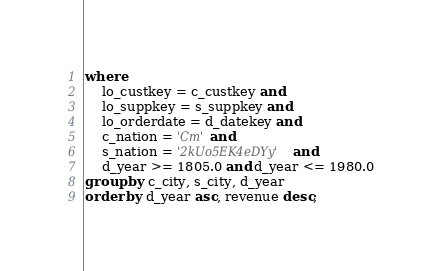<code> <loc_0><loc_0><loc_500><loc_500><_SQL_>where
    lo_custkey = c_custkey and
    lo_suppkey = s_suppkey and
    lo_orderdate = d_datekey and
    c_nation = 'Cm' and
    s_nation = '2kUo5EK4eDYy' and
    d_year >= 1805.0 and d_year <= 1980.0
group by c_city, s_city, d_year
order by d_year asc, revenue desc;
</code> 